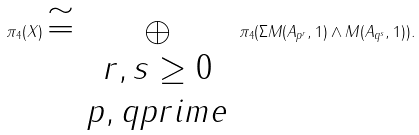<formula> <loc_0><loc_0><loc_500><loc_500>\pi _ { 4 } ( X ) \cong \bigoplus _ { \begin{array} { c } r , s \geq 0 \\ p , q p r i m e \\ \end{array} } \pi _ { 4 } ( \Sigma M ( A _ { p ^ { r } } , 1 ) \wedge M ( A _ { q ^ { s } } , 1 ) ) .</formula> 